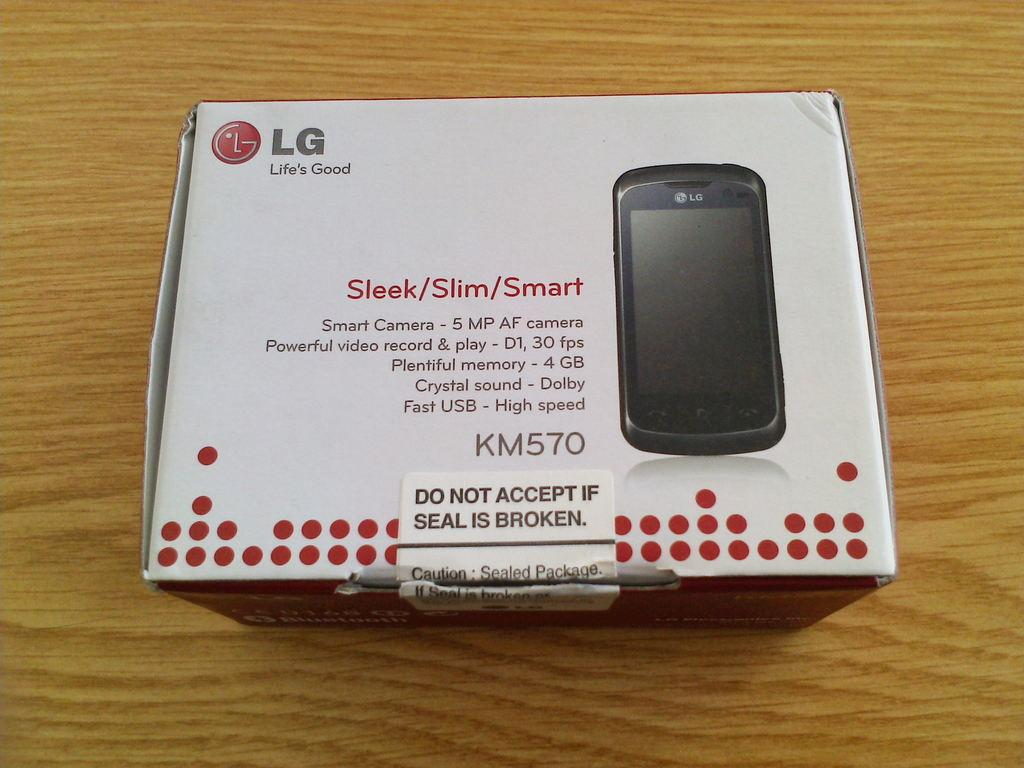<image>
Present a compact description of the photo's key features. A box with a broken seal is labeled as an LG phone. 